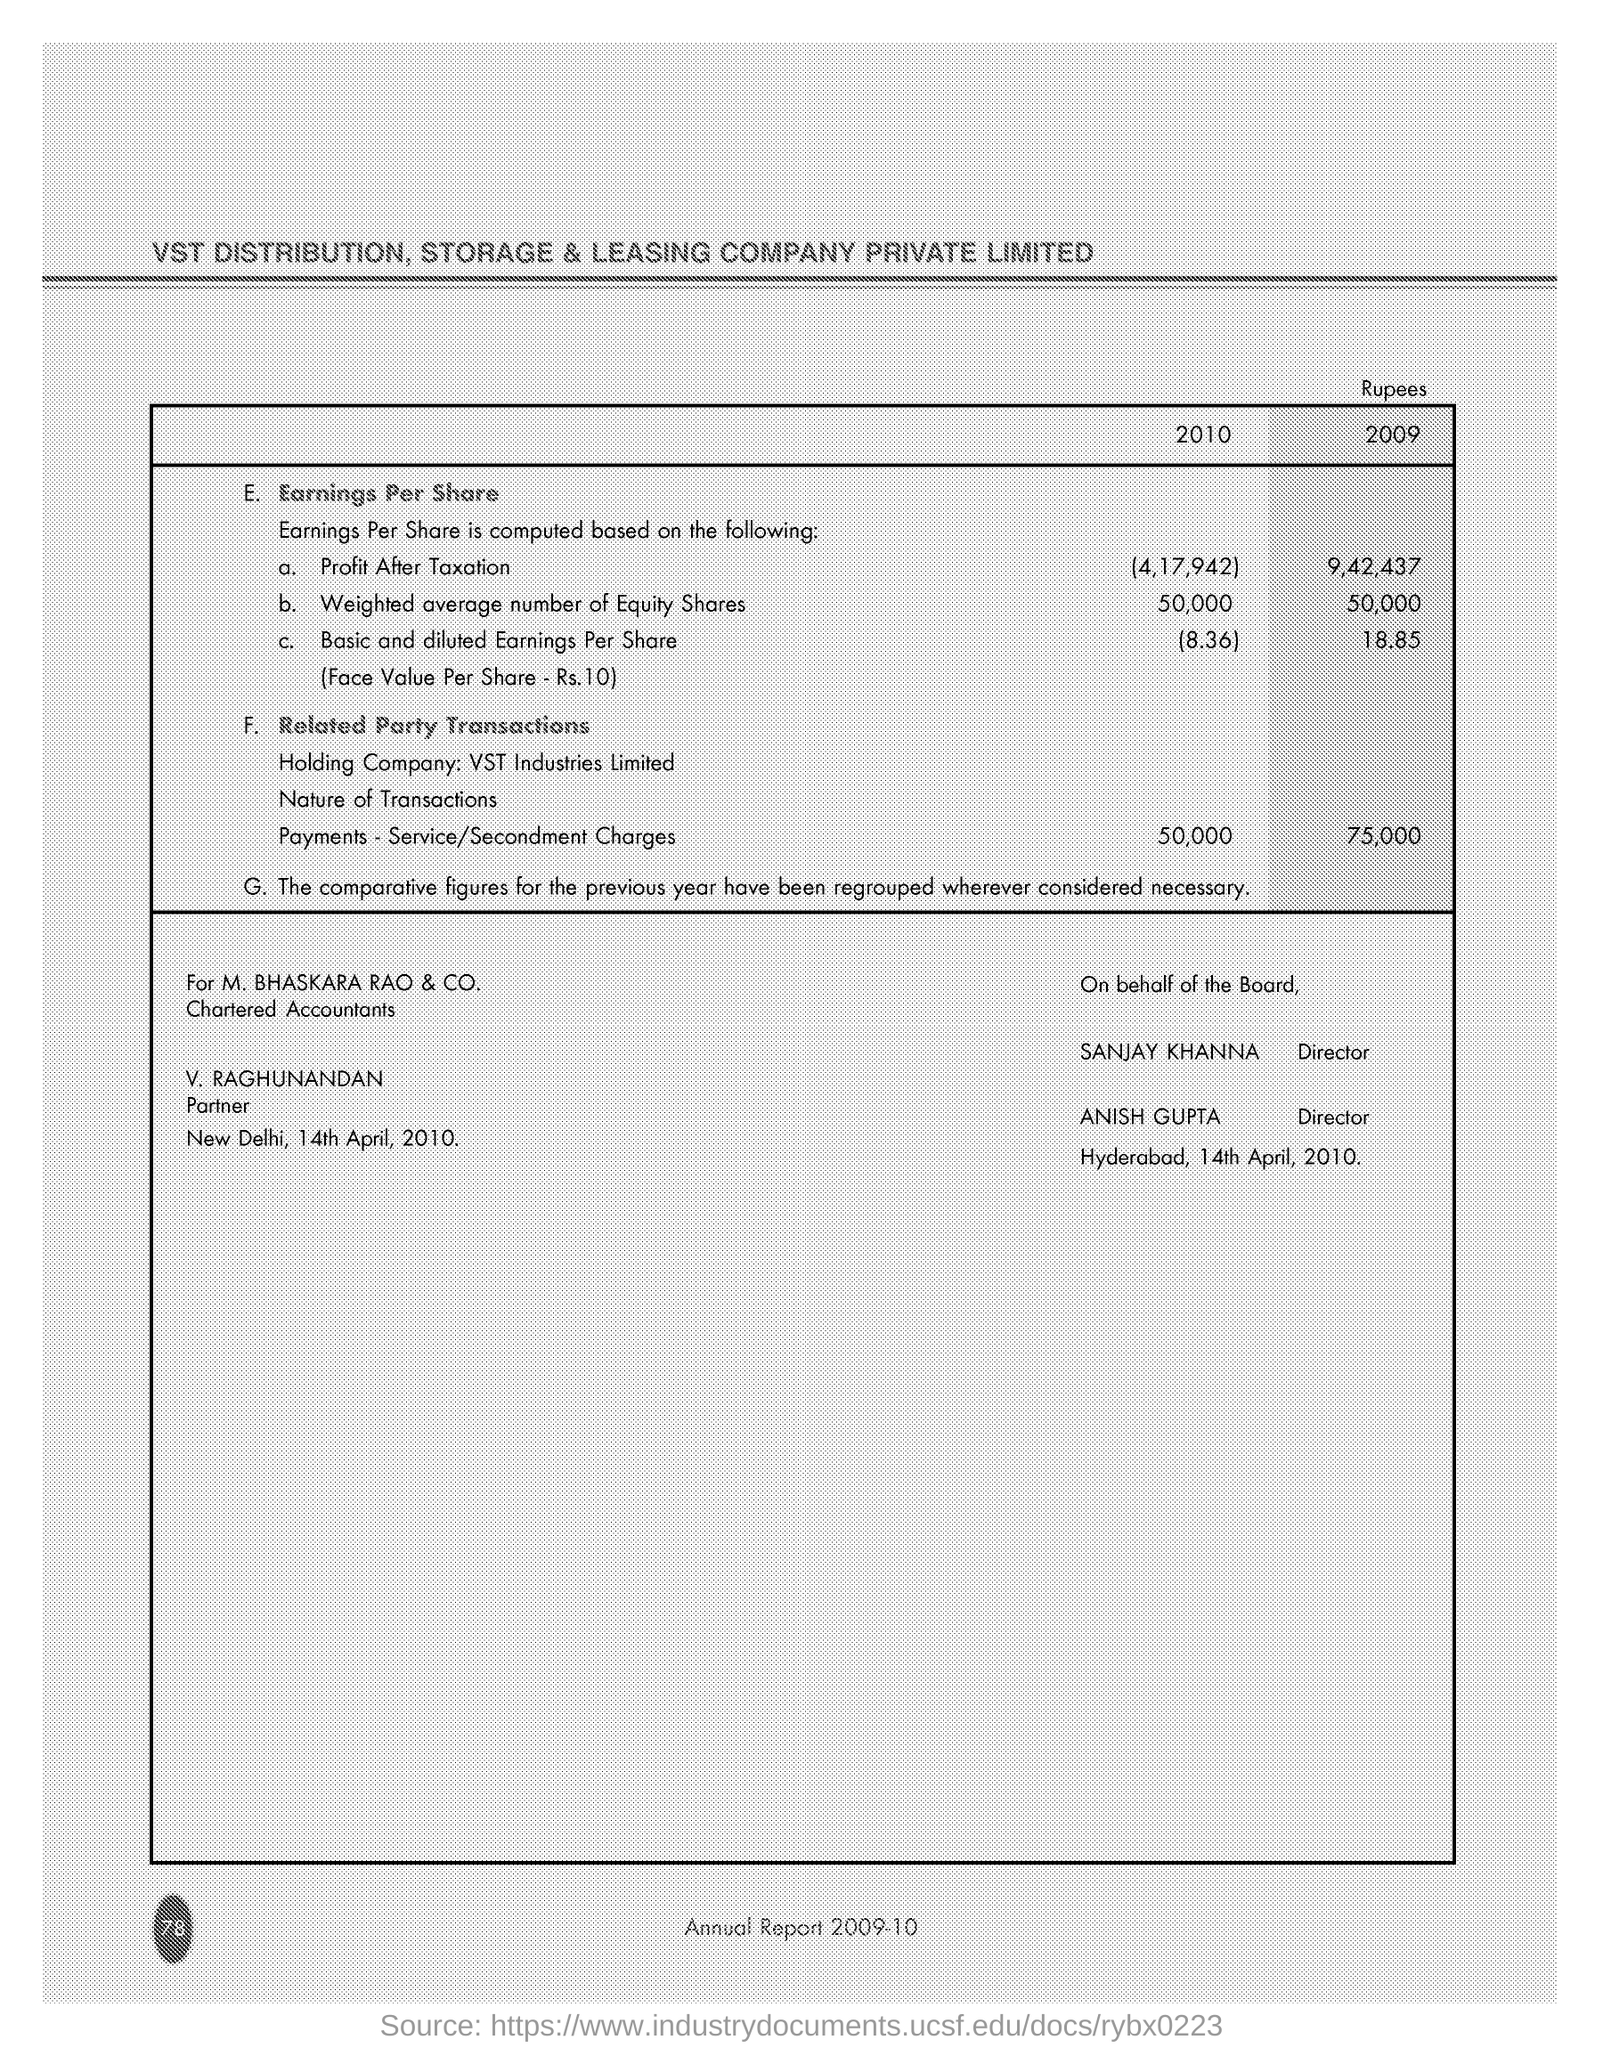What is the Title of the document ?
Make the answer very short. VST DISTRIBUTION, STORAGE & LEASING COMPANY PRIVATE LIMITED. How much profit after taxation in 2010 ?
Offer a terse response. 4,17,942. What is the date mentioned in the bottom of the document ?
Offer a very short reply. 14th April, 2010. Who is the Partner ?
Your answer should be very brief. V. RAGHUNANDAN. 